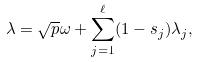Convert formula to latex. <formula><loc_0><loc_0><loc_500><loc_500>\lambda = \sqrt { p } \omega + \sum _ { j = 1 } ^ { \ell } ( 1 - s _ { j } ) \lambda _ { j } ,</formula> 